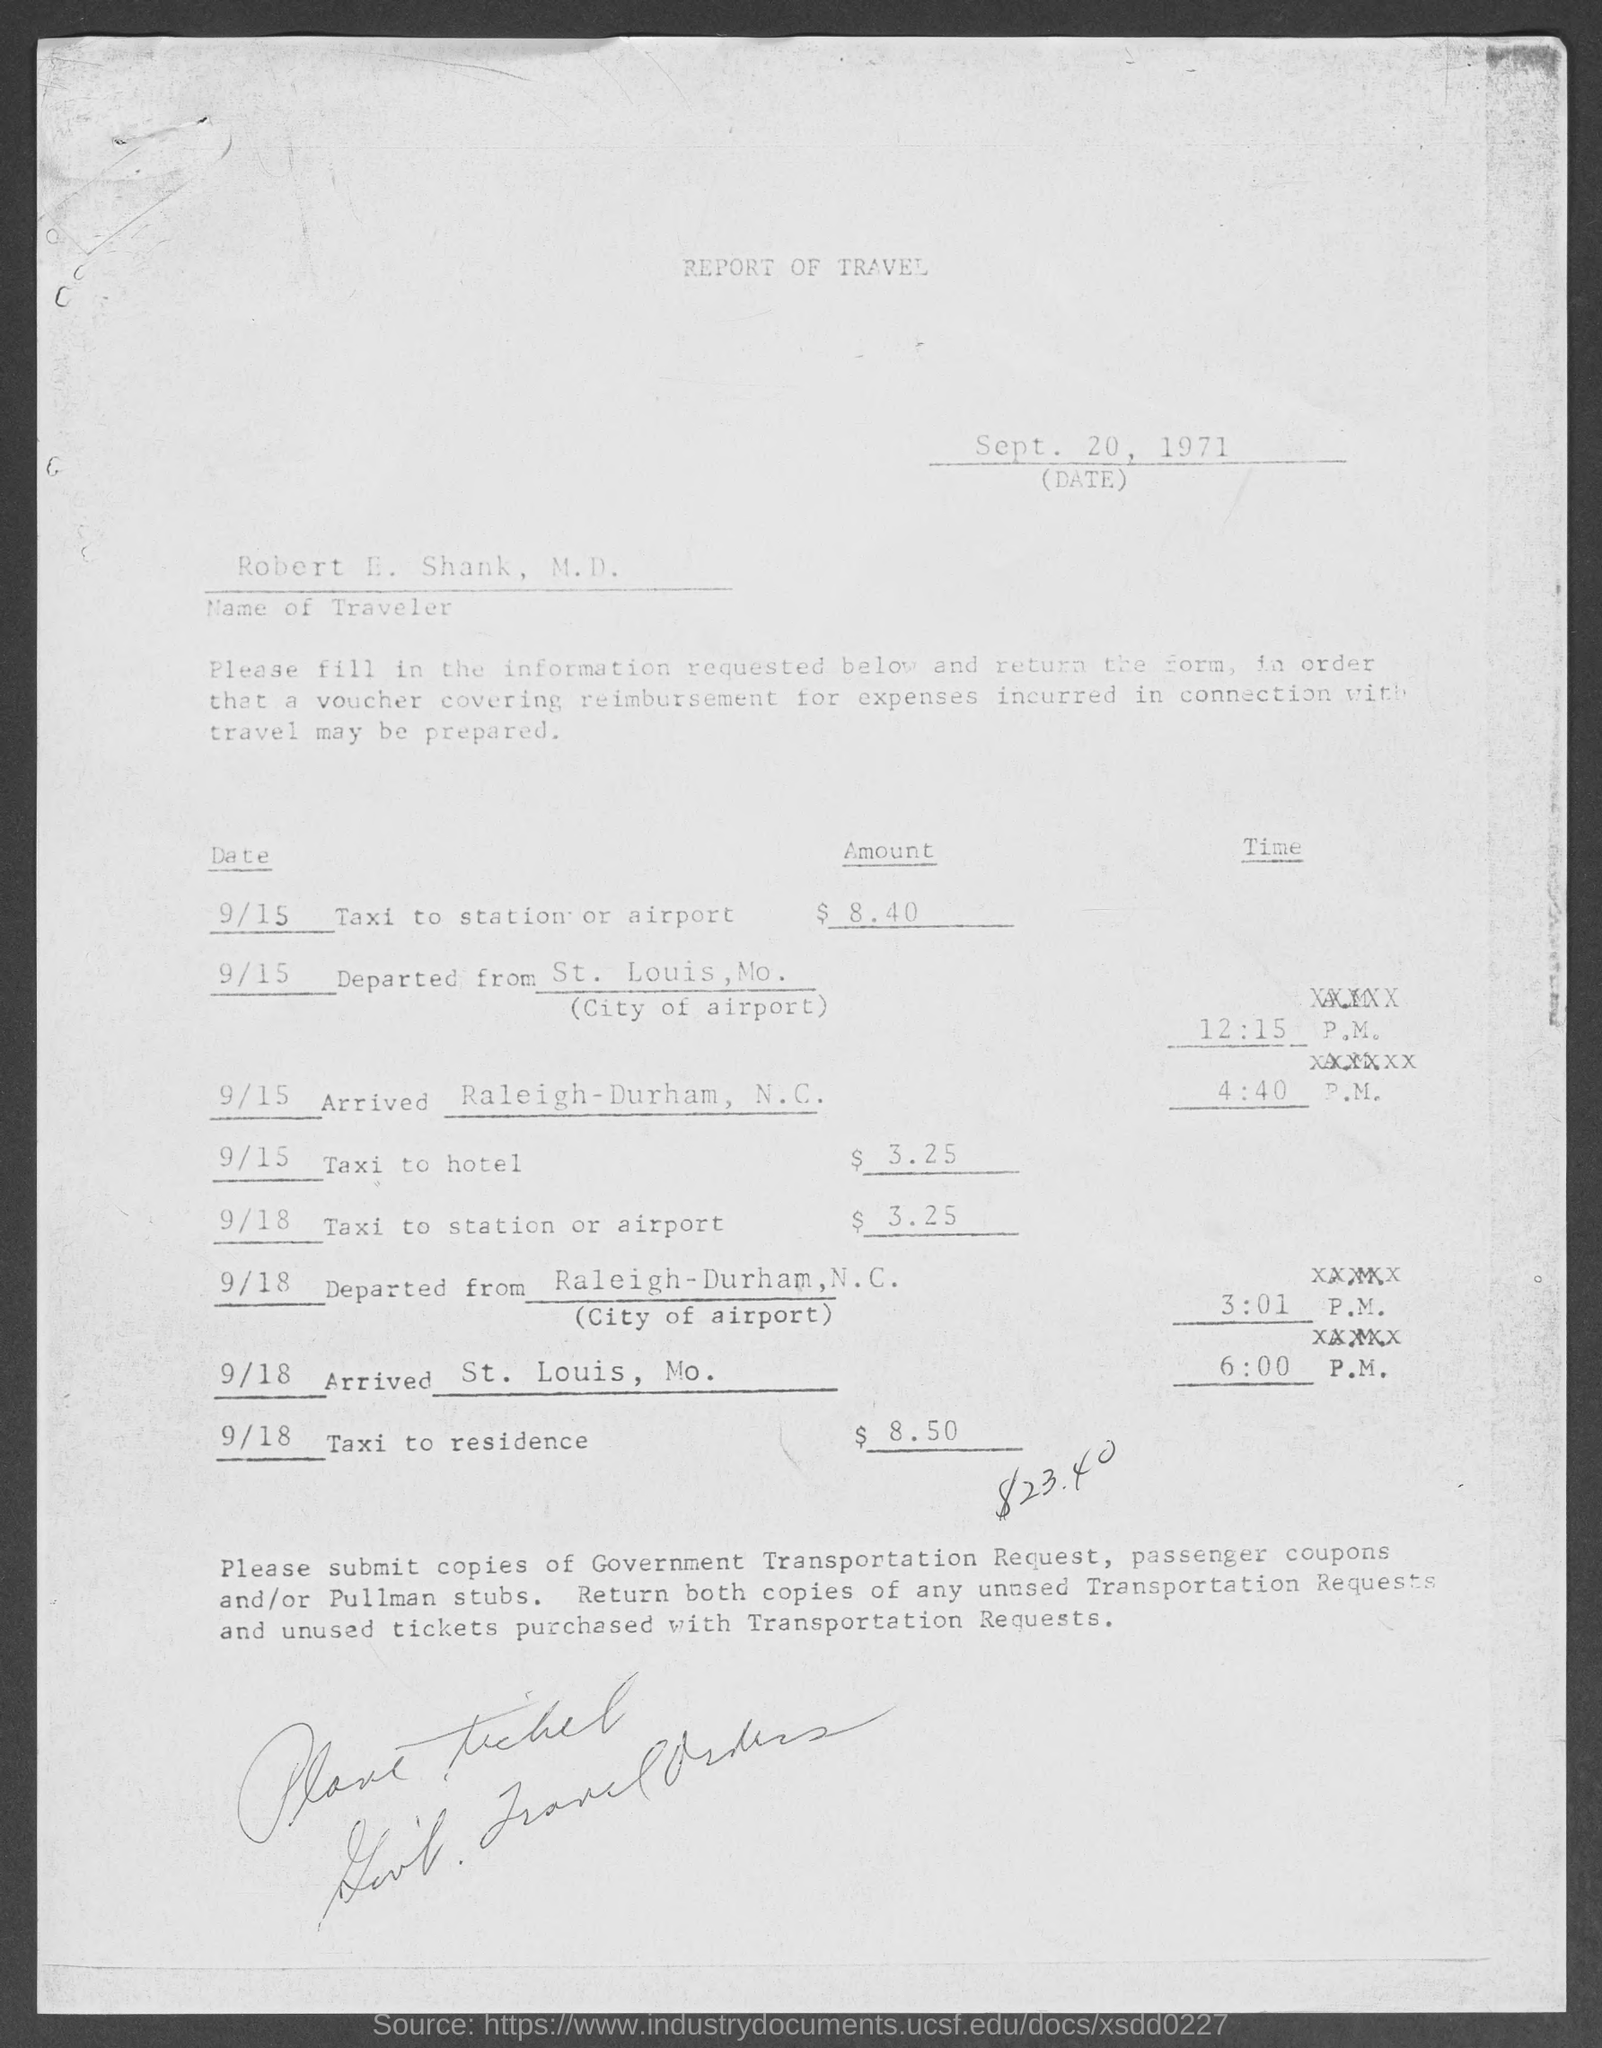Give some essential details in this illustration. The traveler's name is Robert E. Shank, M.D. The Report of Travel, dated September 20, 1971, was issued on that date. 